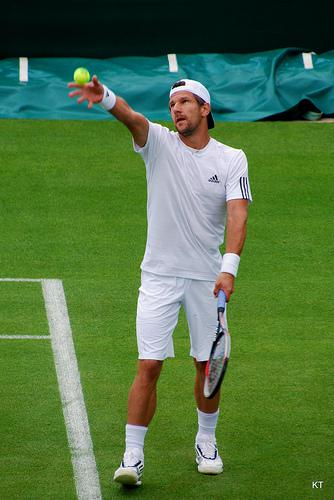Question: who is with the man?
Choices:
A. 1 person.
B. No one.
C. 2 people.
D. 3 people.
Answer with the letter. Answer: B Question: what is on the man's head?
Choices:
A. Hat.
B. Visor.
C. Headband.
D. Turban.
Answer with the letter. Answer: A Question: what color is the man wearing?
Choices:
A. Blue.
B. Black.
C. Purple.
D. White.
Answer with the letter. Answer: D Question: what is in the man's hand?
Choices:
A. Baseball bat.
B. Lacrosse stick.
C. Hockey stick.
D. Tennis racket.
Answer with the letter. Answer: D 